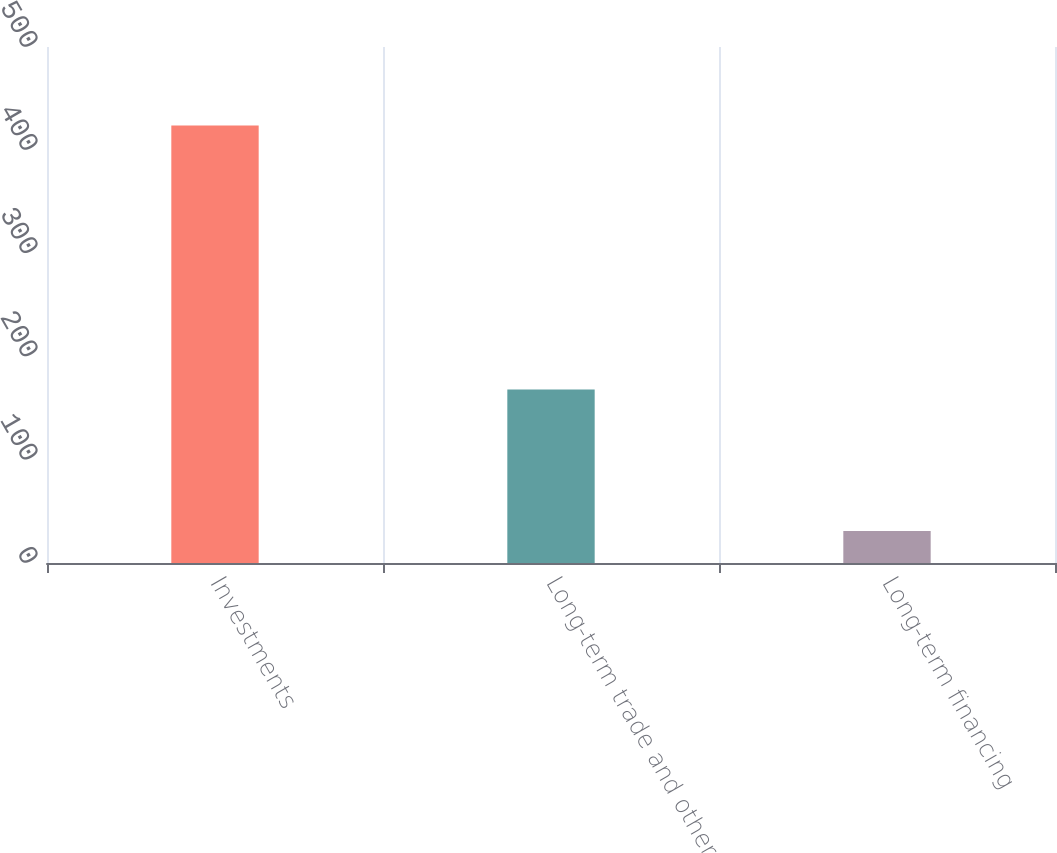Convert chart to OTSL. <chart><loc_0><loc_0><loc_500><loc_500><bar_chart><fcel>Investments<fcel>Long-term trade and other<fcel>Long-term financing<nl><fcel>424<fcel>168<fcel>31<nl></chart> 